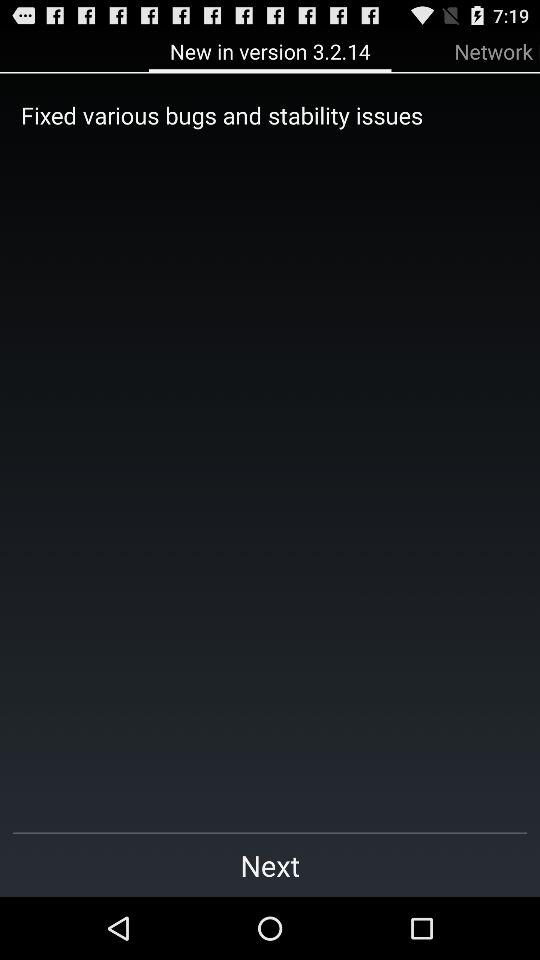What version is this? The version is 3.2.14. 